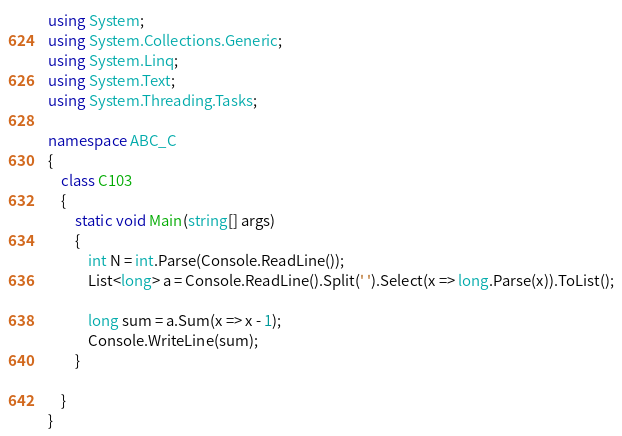Convert code to text. <code><loc_0><loc_0><loc_500><loc_500><_C#_>using System;
using System.Collections.Generic;
using System.Linq;
using System.Text;
using System.Threading.Tasks;

namespace ABC_C
{
    class C103
    {
        static void Main(string[] args)
        {
            int N = int.Parse(Console.ReadLine());
            List<long> a = Console.ReadLine().Split(' ').Select(x => long.Parse(x)).ToList();

            long sum = a.Sum(x => x - 1);  
            Console.WriteLine(sum);
        }

    }
}
</code> 